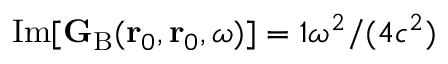<formula> <loc_0><loc_0><loc_500><loc_500>I m [ { G } _ { B } ( r _ { 0 } , r _ { 0 } , \omega ) ] = { \mathbb { 1 } } \omega ^ { 2 } / ( 4 c ^ { 2 } )</formula> 